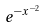<formula> <loc_0><loc_0><loc_500><loc_500>e ^ { - x ^ { - 2 } }</formula> 